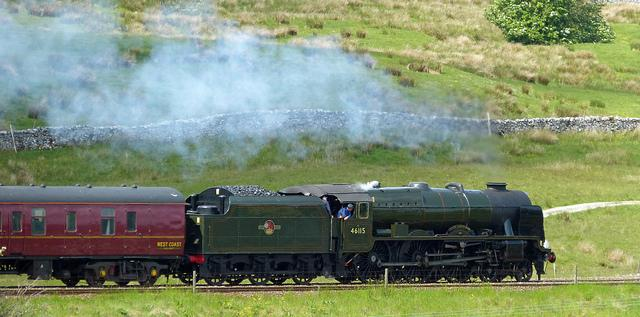Which car propels the train along the tracks?

Choices:
A) back
B) none
C) front
D) middle front 